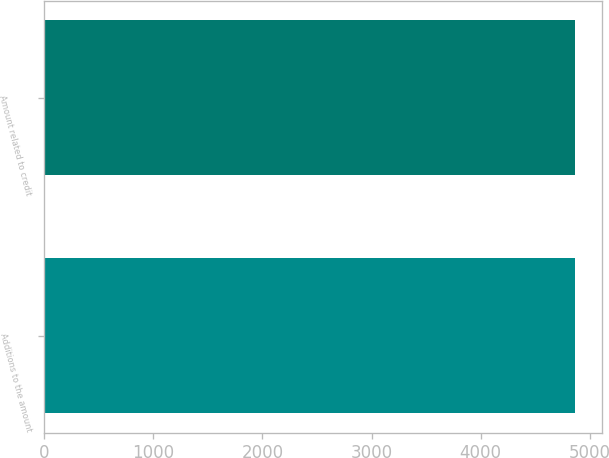<chart> <loc_0><loc_0><loc_500><loc_500><bar_chart><fcel>Additions to the amount<fcel>Amount related to credit<nl><fcel>4869<fcel>4869.1<nl></chart> 